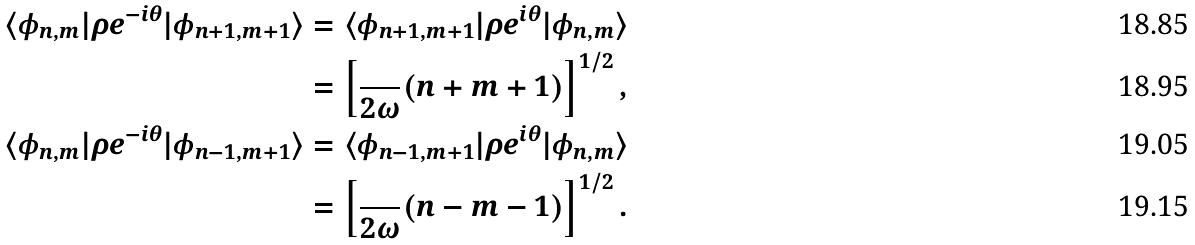Convert formula to latex. <formula><loc_0><loc_0><loc_500><loc_500>\langle \phi _ { n , m } | \rho e ^ { - i \theta } | \phi _ { n + 1 , m + 1 } \rangle & = \langle \phi _ { n + 1 , m + 1 } | \rho e ^ { i \theta } | \phi _ { n , m } \rangle \\ & = \left [ \frac { } { 2 \omega } ( n + m + 1 ) \right ] ^ { 1 / 2 } , \\ \langle \phi _ { n , m } | \rho e ^ { - i \theta } | \phi _ { n - 1 , m + 1 } \rangle & = \langle \phi _ { n - 1 , m + 1 } | \rho e ^ { i \theta } | \phi _ { n , m } \rangle \\ & = \left [ \frac { } { 2 \omega } ( n - m - 1 ) \right ] ^ { 1 / 2 } .</formula> 